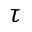Convert formula to latex. <formula><loc_0><loc_0><loc_500><loc_500>\tau</formula> 